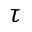Convert formula to latex. <formula><loc_0><loc_0><loc_500><loc_500>\tau</formula> 